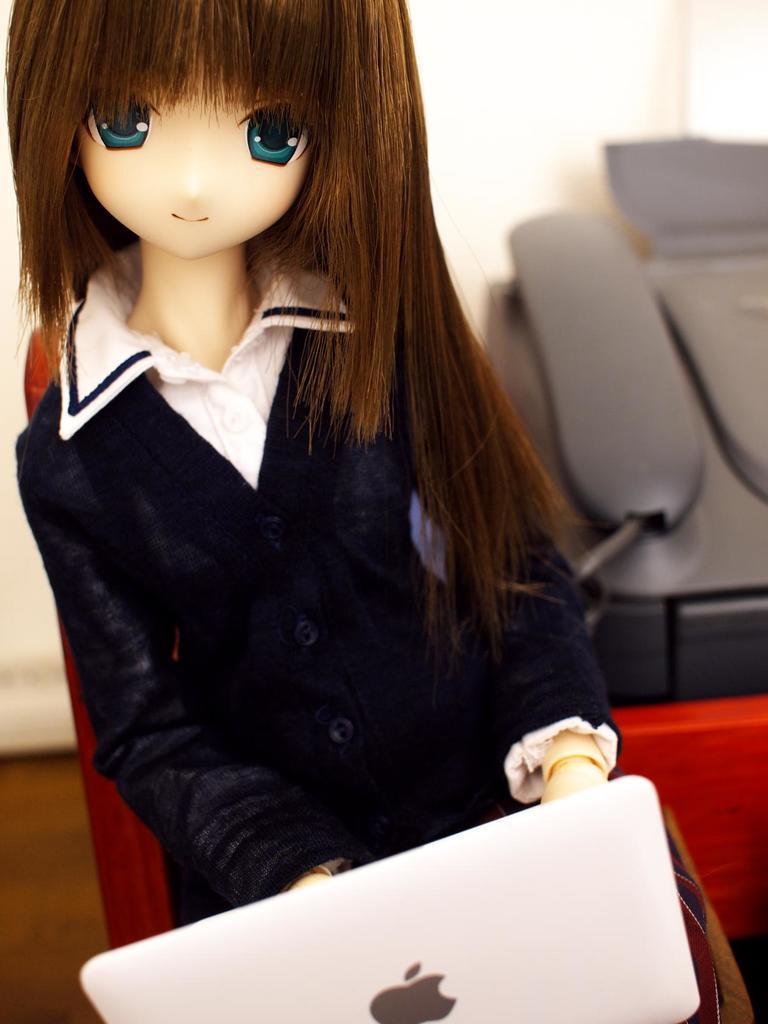Could you give a brief overview of what you see in this image? This picture is clicked inside. In the foreground there is a doll wearing a blue color dress and seems to be sitting and we can see a laptop. In the background there is a wall and a telephone and some other objects. 